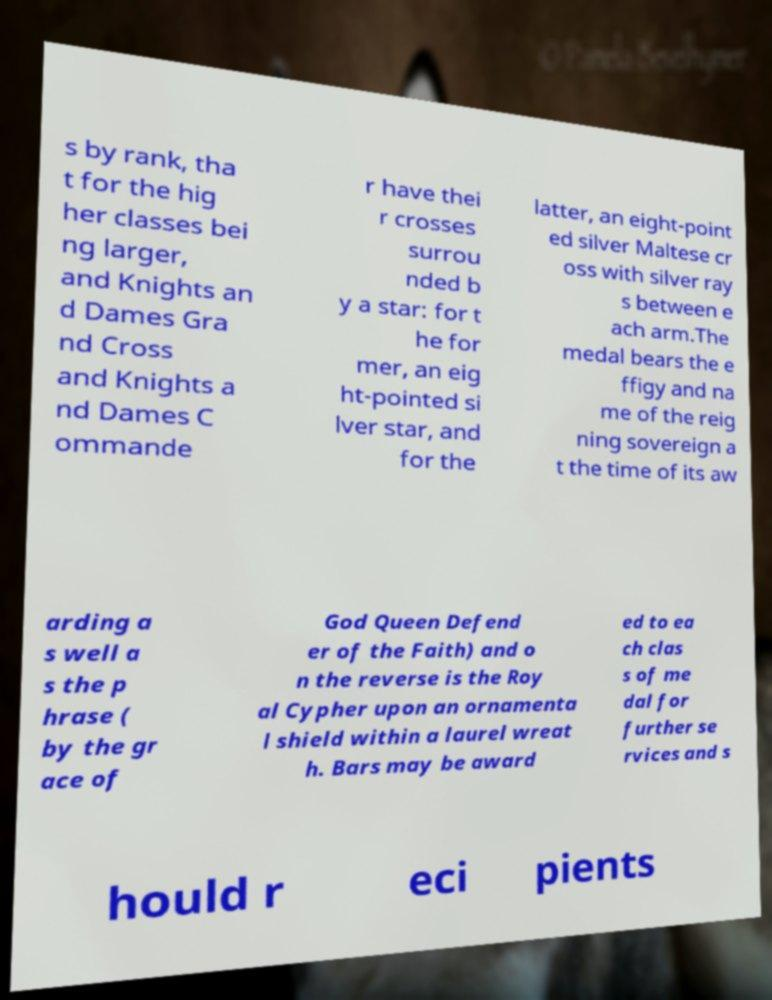I need the written content from this picture converted into text. Can you do that? s by rank, tha t for the hig her classes bei ng larger, and Knights an d Dames Gra nd Cross and Knights a nd Dames C ommande r have thei r crosses surrou nded b y a star: for t he for mer, an eig ht-pointed si lver star, and for the latter, an eight-point ed silver Maltese cr oss with silver ray s between e ach arm.The medal bears the e ffigy and na me of the reig ning sovereign a t the time of its aw arding a s well a s the p hrase ( by the gr ace of God Queen Defend er of the Faith) and o n the reverse is the Roy al Cypher upon an ornamenta l shield within a laurel wreat h. Bars may be award ed to ea ch clas s of me dal for further se rvices and s hould r eci pients 